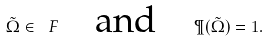<formula> <loc_0><loc_0><loc_500><loc_500>\tilde { \Omega } \in \ F \quad \text {and} \quad \P ( \tilde { \Omega } ) = 1 .</formula> 